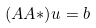<formula> <loc_0><loc_0><loc_500><loc_500>( A A * ) u = b</formula> 